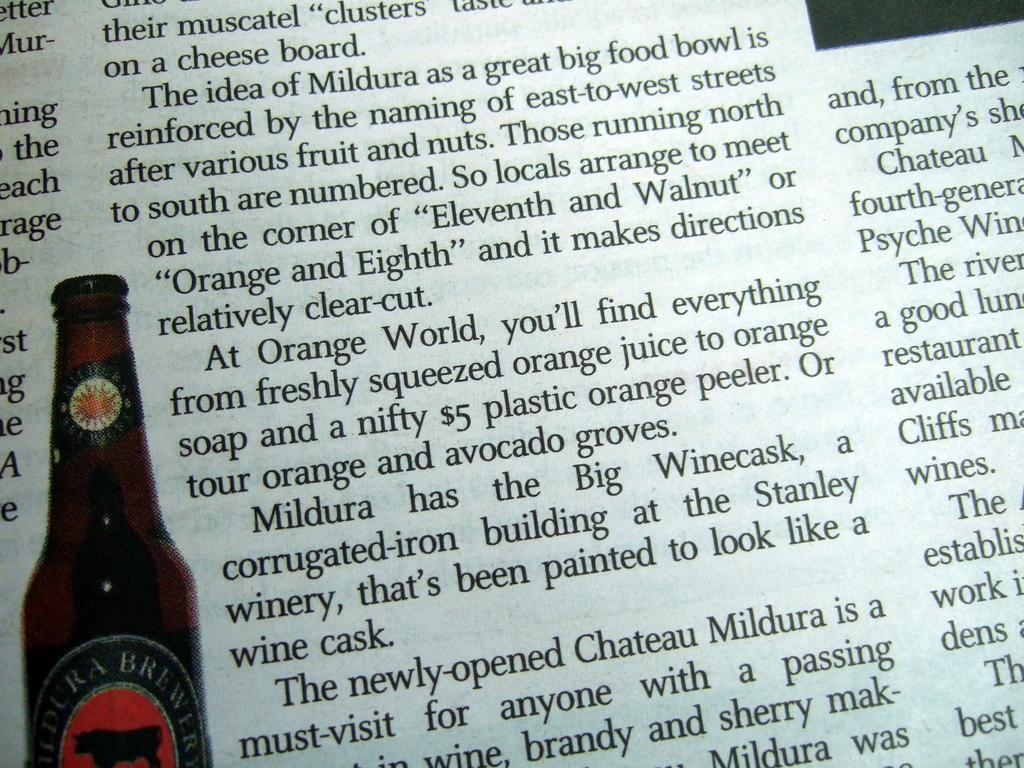Please provide a concise description of this image. In the image I can see a picture of a bottle and something written on the paper. 